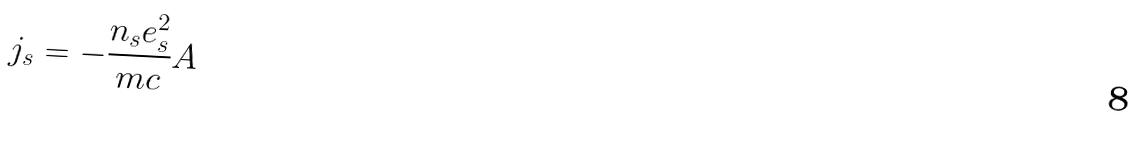Convert formula to latex. <formula><loc_0><loc_0><loc_500><loc_500>j _ { s } = - \frac { n _ { s } e _ { s } ^ { 2 } } { m c } A</formula> 